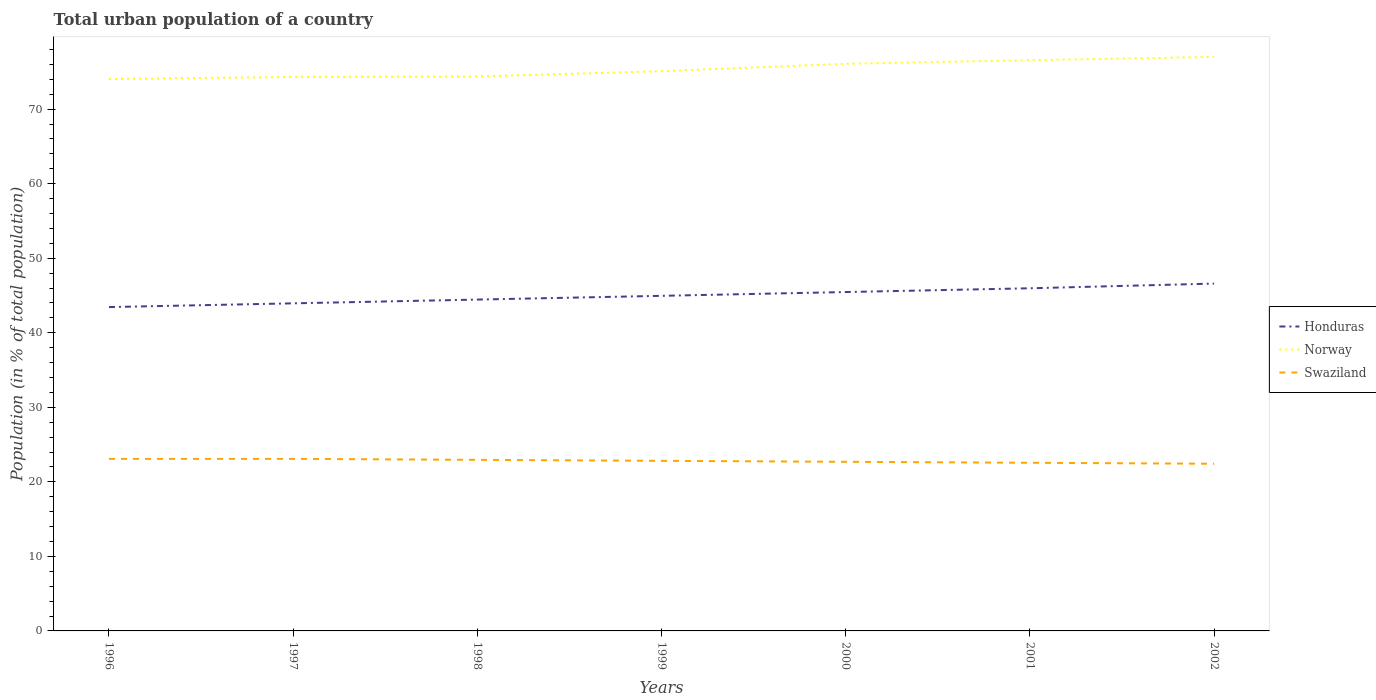Does the line corresponding to Honduras intersect with the line corresponding to Swaziland?
Offer a very short reply. No. Across all years, what is the maximum urban population in Swaziland?
Your answer should be compact. 22.43. In which year was the urban population in Norway maximum?
Your answer should be very brief. 1996. What is the total urban population in Honduras in the graph?
Provide a succinct answer. -1.51. What is the difference between the highest and the second highest urban population in Swaziland?
Keep it short and to the point. 0.66. Does the graph contain grids?
Give a very brief answer. No. How many legend labels are there?
Make the answer very short. 3. What is the title of the graph?
Provide a short and direct response. Total urban population of a country. Does "Barbados" appear as one of the legend labels in the graph?
Make the answer very short. No. What is the label or title of the Y-axis?
Give a very brief answer. Population (in % of total population). What is the Population (in % of total population) in Honduras in 1996?
Your response must be concise. 43.44. What is the Population (in % of total population) of Norway in 1996?
Provide a succinct answer. 74.04. What is the Population (in % of total population) in Swaziland in 1996?
Provide a short and direct response. 23.08. What is the Population (in % of total population) of Honduras in 1997?
Provide a succinct answer. 43.94. What is the Population (in % of total population) in Norway in 1997?
Ensure brevity in your answer.  74.31. What is the Population (in % of total population) in Swaziland in 1997?
Offer a terse response. 23.08. What is the Population (in % of total population) of Honduras in 1998?
Keep it short and to the point. 44.45. What is the Population (in % of total population) in Norway in 1998?
Your response must be concise. 74.38. What is the Population (in % of total population) in Swaziland in 1998?
Offer a very short reply. 22.95. What is the Population (in % of total population) of Honduras in 1999?
Give a very brief answer. 44.95. What is the Population (in % of total population) of Norway in 1999?
Provide a succinct answer. 75.09. What is the Population (in % of total population) of Swaziland in 1999?
Offer a terse response. 22.82. What is the Population (in % of total population) in Honduras in 2000?
Keep it short and to the point. 45.46. What is the Population (in % of total population) of Norway in 2000?
Your answer should be very brief. 76.08. What is the Population (in % of total population) in Swaziland in 2000?
Your answer should be very brief. 22.69. What is the Population (in % of total population) of Honduras in 2001?
Your answer should be very brief. 45.96. What is the Population (in % of total population) of Norway in 2001?
Your response must be concise. 76.56. What is the Population (in % of total population) in Swaziland in 2001?
Your answer should be very brief. 22.55. What is the Population (in % of total population) of Honduras in 2002?
Your response must be concise. 46.59. What is the Population (in % of total population) in Norway in 2002?
Provide a succinct answer. 77. What is the Population (in % of total population) of Swaziland in 2002?
Provide a succinct answer. 22.43. Across all years, what is the maximum Population (in % of total population) of Honduras?
Ensure brevity in your answer.  46.59. Across all years, what is the maximum Population (in % of total population) of Norway?
Provide a short and direct response. 77. Across all years, what is the maximum Population (in % of total population) of Swaziland?
Offer a terse response. 23.08. Across all years, what is the minimum Population (in % of total population) in Honduras?
Your answer should be very brief. 43.44. Across all years, what is the minimum Population (in % of total population) of Norway?
Your answer should be compact. 74.04. Across all years, what is the minimum Population (in % of total population) in Swaziland?
Keep it short and to the point. 22.43. What is the total Population (in % of total population) in Honduras in the graph?
Offer a very short reply. 314.8. What is the total Population (in % of total population) in Norway in the graph?
Keep it short and to the point. 527.45. What is the total Population (in % of total population) of Swaziland in the graph?
Offer a terse response. 159.59. What is the difference between the Population (in % of total population) in Honduras in 1996 and that in 1997?
Your response must be concise. -0.5. What is the difference between the Population (in % of total population) of Norway in 1996 and that in 1997?
Make the answer very short. -0.27. What is the difference between the Population (in % of total population) of Swaziland in 1996 and that in 1997?
Provide a short and direct response. -0.01. What is the difference between the Population (in % of total population) of Honduras in 1996 and that in 1998?
Offer a very short reply. -1. What is the difference between the Population (in % of total population) of Norway in 1996 and that in 1998?
Provide a succinct answer. -0.34. What is the difference between the Population (in % of total population) of Swaziland in 1996 and that in 1998?
Your answer should be very brief. 0.13. What is the difference between the Population (in % of total population) in Honduras in 1996 and that in 1999?
Provide a short and direct response. -1.51. What is the difference between the Population (in % of total population) of Norway in 1996 and that in 1999?
Your response must be concise. -1.05. What is the difference between the Population (in % of total population) in Swaziland in 1996 and that in 1999?
Ensure brevity in your answer.  0.26. What is the difference between the Population (in % of total population) of Honduras in 1996 and that in 2000?
Your answer should be very brief. -2.02. What is the difference between the Population (in % of total population) in Norway in 1996 and that in 2000?
Keep it short and to the point. -2.04. What is the difference between the Population (in % of total population) in Swaziland in 1996 and that in 2000?
Provide a succinct answer. 0.39. What is the difference between the Population (in % of total population) of Honduras in 1996 and that in 2001?
Give a very brief answer. -2.52. What is the difference between the Population (in % of total population) in Norway in 1996 and that in 2001?
Ensure brevity in your answer.  -2.52. What is the difference between the Population (in % of total population) in Swaziland in 1996 and that in 2001?
Provide a short and direct response. 0.52. What is the difference between the Population (in % of total population) of Honduras in 1996 and that in 2002?
Offer a terse response. -3.15. What is the difference between the Population (in % of total population) of Norway in 1996 and that in 2002?
Make the answer very short. -2.96. What is the difference between the Population (in % of total population) of Swaziland in 1996 and that in 2002?
Your answer should be compact. 0.65. What is the difference between the Population (in % of total population) in Honduras in 1997 and that in 1998?
Provide a short and direct response. -0.5. What is the difference between the Population (in % of total population) of Norway in 1997 and that in 1998?
Offer a very short reply. -0.07. What is the difference between the Population (in % of total population) of Swaziland in 1997 and that in 1998?
Provide a short and direct response. 0.13. What is the difference between the Population (in % of total population) of Honduras in 1997 and that in 1999?
Offer a very short reply. -1.01. What is the difference between the Population (in % of total population) in Norway in 1997 and that in 1999?
Keep it short and to the point. -0.78. What is the difference between the Population (in % of total population) in Swaziland in 1997 and that in 1999?
Keep it short and to the point. 0.26. What is the difference between the Population (in % of total population) of Honduras in 1997 and that in 2000?
Your response must be concise. -1.51. What is the difference between the Population (in % of total population) of Norway in 1997 and that in 2000?
Your answer should be very brief. -1.77. What is the difference between the Population (in % of total population) of Swaziland in 1997 and that in 2000?
Ensure brevity in your answer.  0.4. What is the difference between the Population (in % of total population) of Honduras in 1997 and that in 2001?
Make the answer very short. -2.02. What is the difference between the Population (in % of total population) in Norway in 1997 and that in 2001?
Make the answer very short. -2.25. What is the difference between the Population (in % of total population) of Swaziland in 1997 and that in 2001?
Provide a succinct answer. 0.53. What is the difference between the Population (in % of total population) in Honduras in 1997 and that in 2002?
Provide a succinct answer. -2.65. What is the difference between the Population (in % of total population) in Norway in 1997 and that in 2002?
Give a very brief answer. -2.69. What is the difference between the Population (in % of total population) in Swaziland in 1997 and that in 2002?
Offer a very short reply. 0.66. What is the difference between the Population (in % of total population) of Honduras in 1998 and that in 1999?
Keep it short and to the point. -0.51. What is the difference between the Population (in % of total population) in Norway in 1998 and that in 1999?
Provide a succinct answer. -0.71. What is the difference between the Population (in % of total population) in Swaziland in 1998 and that in 1999?
Keep it short and to the point. 0.13. What is the difference between the Population (in % of total population) in Honduras in 1998 and that in 2000?
Provide a short and direct response. -1.01. What is the difference between the Population (in % of total population) of Norway in 1998 and that in 2000?
Make the answer very short. -1.71. What is the difference between the Population (in % of total population) of Swaziland in 1998 and that in 2000?
Give a very brief answer. 0.26. What is the difference between the Population (in % of total population) of Honduras in 1998 and that in 2001?
Your response must be concise. -1.52. What is the difference between the Population (in % of total population) in Norway in 1998 and that in 2001?
Offer a terse response. -2.19. What is the difference between the Population (in % of total population) in Swaziland in 1998 and that in 2001?
Make the answer very short. 0.39. What is the difference between the Population (in % of total population) of Honduras in 1998 and that in 2002?
Provide a short and direct response. -2.15. What is the difference between the Population (in % of total population) of Norway in 1998 and that in 2002?
Provide a short and direct response. -2.62. What is the difference between the Population (in % of total population) in Swaziland in 1998 and that in 2002?
Your response must be concise. 0.52. What is the difference between the Population (in % of total population) in Honduras in 1999 and that in 2000?
Ensure brevity in your answer.  -0.51. What is the difference between the Population (in % of total population) of Norway in 1999 and that in 2000?
Your answer should be compact. -0.99. What is the difference between the Population (in % of total population) in Swaziland in 1999 and that in 2000?
Provide a short and direct response. 0.13. What is the difference between the Population (in % of total population) of Honduras in 1999 and that in 2001?
Ensure brevity in your answer.  -1.01. What is the difference between the Population (in % of total population) in Norway in 1999 and that in 2001?
Give a very brief answer. -1.48. What is the difference between the Population (in % of total population) in Swaziland in 1999 and that in 2001?
Give a very brief answer. 0.26. What is the difference between the Population (in % of total population) in Honduras in 1999 and that in 2002?
Give a very brief answer. -1.64. What is the difference between the Population (in % of total population) in Norway in 1999 and that in 2002?
Your response must be concise. -1.91. What is the difference between the Population (in % of total population) of Swaziland in 1999 and that in 2002?
Make the answer very short. 0.39. What is the difference between the Population (in % of total population) in Honduras in 2000 and that in 2001?
Provide a short and direct response. -0.51. What is the difference between the Population (in % of total population) in Norway in 2000 and that in 2001?
Provide a succinct answer. -0.48. What is the difference between the Population (in % of total population) of Swaziland in 2000 and that in 2001?
Your answer should be very brief. 0.13. What is the difference between the Population (in % of total population) in Honduras in 2000 and that in 2002?
Offer a terse response. -1.14. What is the difference between the Population (in % of total population) in Norway in 2000 and that in 2002?
Ensure brevity in your answer.  -0.92. What is the difference between the Population (in % of total population) of Swaziland in 2000 and that in 2002?
Your response must be concise. 0.26. What is the difference between the Population (in % of total population) in Honduras in 2001 and that in 2002?
Your answer should be compact. -0.63. What is the difference between the Population (in % of total population) in Norway in 2001 and that in 2002?
Offer a terse response. -0.44. What is the difference between the Population (in % of total population) of Swaziland in 2001 and that in 2002?
Your response must be concise. 0.13. What is the difference between the Population (in % of total population) of Honduras in 1996 and the Population (in % of total population) of Norway in 1997?
Offer a terse response. -30.87. What is the difference between the Population (in % of total population) of Honduras in 1996 and the Population (in % of total population) of Swaziland in 1997?
Your answer should be compact. 20.36. What is the difference between the Population (in % of total population) in Norway in 1996 and the Population (in % of total population) in Swaziland in 1997?
Ensure brevity in your answer.  50.96. What is the difference between the Population (in % of total population) of Honduras in 1996 and the Population (in % of total population) of Norway in 1998?
Keep it short and to the point. -30.93. What is the difference between the Population (in % of total population) of Honduras in 1996 and the Population (in % of total population) of Swaziland in 1998?
Provide a succinct answer. 20.49. What is the difference between the Population (in % of total population) of Norway in 1996 and the Population (in % of total population) of Swaziland in 1998?
Make the answer very short. 51.09. What is the difference between the Population (in % of total population) in Honduras in 1996 and the Population (in % of total population) in Norway in 1999?
Your answer should be compact. -31.64. What is the difference between the Population (in % of total population) in Honduras in 1996 and the Population (in % of total population) in Swaziland in 1999?
Ensure brevity in your answer.  20.62. What is the difference between the Population (in % of total population) of Norway in 1996 and the Population (in % of total population) of Swaziland in 1999?
Your response must be concise. 51.22. What is the difference between the Population (in % of total population) in Honduras in 1996 and the Population (in % of total population) in Norway in 2000?
Ensure brevity in your answer.  -32.64. What is the difference between the Population (in % of total population) in Honduras in 1996 and the Population (in % of total population) in Swaziland in 2000?
Give a very brief answer. 20.76. What is the difference between the Population (in % of total population) in Norway in 1996 and the Population (in % of total population) in Swaziland in 2000?
Your answer should be compact. 51.35. What is the difference between the Population (in % of total population) of Honduras in 1996 and the Population (in % of total population) of Norway in 2001?
Your answer should be compact. -33.12. What is the difference between the Population (in % of total population) of Honduras in 1996 and the Population (in % of total population) of Swaziland in 2001?
Provide a succinct answer. 20.89. What is the difference between the Population (in % of total population) in Norway in 1996 and the Population (in % of total population) in Swaziland in 2001?
Provide a short and direct response. 51.48. What is the difference between the Population (in % of total population) in Honduras in 1996 and the Population (in % of total population) in Norway in 2002?
Give a very brief answer. -33.56. What is the difference between the Population (in % of total population) of Honduras in 1996 and the Population (in % of total population) of Swaziland in 2002?
Provide a succinct answer. 21.02. What is the difference between the Population (in % of total population) of Norway in 1996 and the Population (in % of total population) of Swaziland in 2002?
Offer a terse response. 51.61. What is the difference between the Population (in % of total population) of Honduras in 1997 and the Population (in % of total population) of Norway in 1998?
Provide a short and direct response. -30.43. What is the difference between the Population (in % of total population) in Honduras in 1997 and the Population (in % of total population) in Swaziland in 1998?
Provide a succinct answer. 21. What is the difference between the Population (in % of total population) of Norway in 1997 and the Population (in % of total population) of Swaziland in 1998?
Offer a terse response. 51.36. What is the difference between the Population (in % of total population) in Honduras in 1997 and the Population (in % of total population) in Norway in 1999?
Offer a very short reply. -31.14. What is the difference between the Population (in % of total population) in Honduras in 1997 and the Population (in % of total population) in Swaziland in 1999?
Offer a very short reply. 21.13. What is the difference between the Population (in % of total population) of Norway in 1997 and the Population (in % of total population) of Swaziland in 1999?
Offer a terse response. 51.49. What is the difference between the Population (in % of total population) in Honduras in 1997 and the Population (in % of total population) in Norway in 2000?
Offer a terse response. -32.14. What is the difference between the Population (in % of total population) of Honduras in 1997 and the Population (in % of total population) of Swaziland in 2000?
Keep it short and to the point. 21.26. What is the difference between the Population (in % of total population) of Norway in 1997 and the Population (in % of total population) of Swaziland in 2000?
Provide a short and direct response. 51.62. What is the difference between the Population (in % of total population) of Honduras in 1997 and the Population (in % of total population) of Norway in 2001?
Give a very brief answer. -32.62. What is the difference between the Population (in % of total population) in Honduras in 1997 and the Population (in % of total population) in Swaziland in 2001?
Provide a succinct answer. 21.39. What is the difference between the Population (in % of total population) in Norway in 1997 and the Population (in % of total population) in Swaziland in 2001?
Keep it short and to the point. 51.75. What is the difference between the Population (in % of total population) in Honduras in 1997 and the Population (in % of total population) in Norway in 2002?
Offer a terse response. -33.05. What is the difference between the Population (in % of total population) in Honduras in 1997 and the Population (in % of total population) in Swaziland in 2002?
Provide a short and direct response. 21.52. What is the difference between the Population (in % of total population) in Norway in 1997 and the Population (in % of total population) in Swaziland in 2002?
Provide a short and direct response. 51.88. What is the difference between the Population (in % of total population) of Honduras in 1998 and the Population (in % of total population) of Norway in 1999?
Ensure brevity in your answer.  -30.64. What is the difference between the Population (in % of total population) in Honduras in 1998 and the Population (in % of total population) in Swaziland in 1999?
Keep it short and to the point. 21.63. What is the difference between the Population (in % of total population) of Norway in 1998 and the Population (in % of total population) of Swaziland in 1999?
Your answer should be very brief. 51.56. What is the difference between the Population (in % of total population) in Honduras in 1998 and the Population (in % of total population) in Norway in 2000?
Make the answer very short. -31.63. What is the difference between the Population (in % of total population) in Honduras in 1998 and the Population (in % of total population) in Swaziland in 2000?
Make the answer very short. 21.76. What is the difference between the Population (in % of total population) of Norway in 1998 and the Population (in % of total population) of Swaziland in 2000?
Your answer should be compact. 51.69. What is the difference between the Population (in % of total population) in Honduras in 1998 and the Population (in % of total population) in Norway in 2001?
Provide a short and direct response. -32.11. What is the difference between the Population (in % of total population) in Honduras in 1998 and the Population (in % of total population) in Swaziland in 2001?
Your response must be concise. 21.89. What is the difference between the Population (in % of total population) of Norway in 1998 and the Population (in % of total population) of Swaziland in 2001?
Your response must be concise. 51.82. What is the difference between the Population (in % of total population) of Honduras in 1998 and the Population (in % of total population) of Norway in 2002?
Make the answer very short. -32.55. What is the difference between the Population (in % of total population) of Honduras in 1998 and the Population (in % of total population) of Swaziland in 2002?
Provide a short and direct response. 22.02. What is the difference between the Population (in % of total population) of Norway in 1998 and the Population (in % of total population) of Swaziland in 2002?
Make the answer very short. 51.95. What is the difference between the Population (in % of total population) in Honduras in 1999 and the Population (in % of total population) in Norway in 2000?
Offer a very short reply. -31.13. What is the difference between the Population (in % of total population) in Honduras in 1999 and the Population (in % of total population) in Swaziland in 2000?
Your response must be concise. 22.27. What is the difference between the Population (in % of total population) in Norway in 1999 and the Population (in % of total population) in Swaziland in 2000?
Give a very brief answer. 52.4. What is the difference between the Population (in % of total population) of Honduras in 1999 and the Population (in % of total population) of Norway in 2001?
Your answer should be very brief. -31.61. What is the difference between the Population (in % of total population) of Honduras in 1999 and the Population (in % of total population) of Swaziland in 2001?
Your answer should be very brief. 22.4. What is the difference between the Population (in % of total population) in Norway in 1999 and the Population (in % of total population) in Swaziland in 2001?
Provide a short and direct response. 52.53. What is the difference between the Population (in % of total population) of Honduras in 1999 and the Population (in % of total population) of Norway in 2002?
Your response must be concise. -32.05. What is the difference between the Population (in % of total population) in Honduras in 1999 and the Population (in % of total population) in Swaziland in 2002?
Offer a terse response. 22.53. What is the difference between the Population (in % of total population) in Norway in 1999 and the Population (in % of total population) in Swaziland in 2002?
Make the answer very short. 52.66. What is the difference between the Population (in % of total population) in Honduras in 2000 and the Population (in % of total population) in Norway in 2001?
Your answer should be very brief. -31.1. What is the difference between the Population (in % of total population) in Honduras in 2000 and the Population (in % of total population) in Swaziland in 2001?
Your answer should be compact. 22.9. What is the difference between the Population (in % of total population) in Norway in 2000 and the Population (in % of total population) in Swaziland in 2001?
Ensure brevity in your answer.  53.53. What is the difference between the Population (in % of total population) in Honduras in 2000 and the Population (in % of total population) in Norway in 2002?
Ensure brevity in your answer.  -31.54. What is the difference between the Population (in % of total population) of Honduras in 2000 and the Population (in % of total population) of Swaziland in 2002?
Your answer should be compact. 23.03. What is the difference between the Population (in % of total population) of Norway in 2000 and the Population (in % of total population) of Swaziland in 2002?
Offer a very short reply. 53.66. What is the difference between the Population (in % of total population) of Honduras in 2001 and the Population (in % of total population) of Norway in 2002?
Your answer should be compact. -31.04. What is the difference between the Population (in % of total population) of Honduras in 2001 and the Population (in % of total population) of Swaziland in 2002?
Keep it short and to the point. 23.54. What is the difference between the Population (in % of total population) in Norway in 2001 and the Population (in % of total population) in Swaziland in 2002?
Your answer should be very brief. 54.14. What is the average Population (in % of total population) in Honduras per year?
Ensure brevity in your answer.  44.97. What is the average Population (in % of total population) of Norway per year?
Your answer should be compact. 75.35. What is the average Population (in % of total population) in Swaziland per year?
Provide a succinct answer. 22.8. In the year 1996, what is the difference between the Population (in % of total population) of Honduras and Population (in % of total population) of Norway?
Keep it short and to the point. -30.6. In the year 1996, what is the difference between the Population (in % of total population) in Honduras and Population (in % of total population) in Swaziland?
Provide a short and direct response. 20.37. In the year 1996, what is the difference between the Population (in % of total population) of Norway and Population (in % of total population) of Swaziland?
Provide a short and direct response. 50.96. In the year 1997, what is the difference between the Population (in % of total population) of Honduras and Population (in % of total population) of Norway?
Give a very brief answer. -30.36. In the year 1997, what is the difference between the Population (in % of total population) of Honduras and Population (in % of total population) of Swaziland?
Provide a succinct answer. 20.86. In the year 1997, what is the difference between the Population (in % of total population) of Norway and Population (in % of total population) of Swaziland?
Your response must be concise. 51.23. In the year 1998, what is the difference between the Population (in % of total population) in Honduras and Population (in % of total population) in Norway?
Provide a succinct answer. -29.93. In the year 1998, what is the difference between the Population (in % of total population) of Honduras and Population (in % of total population) of Swaziland?
Make the answer very short. 21.5. In the year 1998, what is the difference between the Population (in % of total population) of Norway and Population (in % of total population) of Swaziland?
Give a very brief answer. 51.43. In the year 1999, what is the difference between the Population (in % of total population) in Honduras and Population (in % of total population) in Norway?
Your answer should be very brief. -30.13. In the year 1999, what is the difference between the Population (in % of total population) in Honduras and Population (in % of total population) in Swaziland?
Your answer should be very brief. 22.14. In the year 1999, what is the difference between the Population (in % of total population) of Norway and Population (in % of total population) of Swaziland?
Your answer should be compact. 52.27. In the year 2000, what is the difference between the Population (in % of total population) of Honduras and Population (in % of total population) of Norway?
Your response must be concise. -30.62. In the year 2000, what is the difference between the Population (in % of total population) in Honduras and Population (in % of total population) in Swaziland?
Keep it short and to the point. 22.77. In the year 2000, what is the difference between the Population (in % of total population) of Norway and Population (in % of total population) of Swaziland?
Provide a short and direct response. 53.4. In the year 2001, what is the difference between the Population (in % of total population) of Honduras and Population (in % of total population) of Norway?
Give a very brief answer. -30.6. In the year 2001, what is the difference between the Population (in % of total population) in Honduras and Population (in % of total population) in Swaziland?
Give a very brief answer. 23.41. In the year 2001, what is the difference between the Population (in % of total population) in Norway and Population (in % of total population) in Swaziland?
Provide a short and direct response. 54.01. In the year 2002, what is the difference between the Population (in % of total population) in Honduras and Population (in % of total population) in Norway?
Ensure brevity in your answer.  -30.41. In the year 2002, what is the difference between the Population (in % of total population) of Honduras and Population (in % of total population) of Swaziland?
Ensure brevity in your answer.  24.17. In the year 2002, what is the difference between the Population (in % of total population) of Norway and Population (in % of total population) of Swaziland?
Offer a terse response. 54.57. What is the ratio of the Population (in % of total population) of Honduras in 1996 to that in 1997?
Provide a short and direct response. 0.99. What is the ratio of the Population (in % of total population) of Norway in 1996 to that in 1997?
Offer a terse response. 1. What is the ratio of the Population (in % of total population) of Swaziland in 1996 to that in 1997?
Provide a succinct answer. 1. What is the ratio of the Population (in % of total population) in Honduras in 1996 to that in 1998?
Your answer should be compact. 0.98. What is the ratio of the Population (in % of total population) in Honduras in 1996 to that in 1999?
Ensure brevity in your answer.  0.97. What is the ratio of the Population (in % of total population) in Norway in 1996 to that in 1999?
Offer a terse response. 0.99. What is the ratio of the Population (in % of total population) of Swaziland in 1996 to that in 1999?
Make the answer very short. 1.01. What is the ratio of the Population (in % of total population) of Honduras in 1996 to that in 2000?
Ensure brevity in your answer.  0.96. What is the ratio of the Population (in % of total population) in Norway in 1996 to that in 2000?
Your answer should be compact. 0.97. What is the ratio of the Population (in % of total population) in Swaziland in 1996 to that in 2000?
Your answer should be very brief. 1.02. What is the ratio of the Population (in % of total population) of Honduras in 1996 to that in 2001?
Offer a very short reply. 0.95. What is the ratio of the Population (in % of total population) of Norway in 1996 to that in 2001?
Make the answer very short. 0.97. What is the ratio of the Population (in % of total population) of Swaziland in 1996 to that in 2001?
Ensure brevity in your answer.  1.02. What is the ratio of the Population (in % of total population) in Honduras in 1996 to that in 2002?
Provide a short and direct response. 0.93. What is the ratio of the Population (in % of total population) in Norway in 1996 to that in 2002?
Offer a very short reply. 0.96. What is the ratio of the Population (in % of total population) in Swaziland in 1996 to that in 2002?
Your response must be concise. 1.03. What is the ratio of the Population (in % of total population) in Honduras in 1997 to that in 1998?
Provide a short and direct response. 0.99. What is the ratio of the Population (in % of total population) of Norway in 1997 to that in 1998?
Your answer should be compact. 1. What is the ratio of the Population (in % of total population) of Swaziland in 1997 to that in 1998?
Ensure brevity in your answer.  1.01. What is the ratio of the Population (in % of total population) in Honduras in 1997 to that in 1999?
Ensure brevity in your answer.  0.98. What is the ratio of the Population (in % of total population) of Swaziland in 1997 to that in 1999?
Your response must be concise. 1.01. What is the ratio of the Population (in % of total population) of Honduras in 1997 to that in 2000?
Your answer should be very brief. 0.97. What is the ratio of the Population (in % of total population) of Norway in 1997 to that in 2000?
Give a very brief answer. 0.98. What is the ratio of the Population (in % of total population) in Swaziland in 1997 to that in 2000?
Provide a short and direct response. 1.02. What is the ratio of the Population (in % of total population) of Honduras in 1997 to that in 2001?
Your answer should be very brief. 0.96. What is the ratio of the Population (in % of total population) in Norway in 1997 to that in 2001?
Make the answer very short. 0.97. What is the ratio of the Population (in % of total population) in Swaziland in 1997 to that in 2001?
Provide a short and direct response. 1.02. What is the ratio of the Population (in % of total population) in Honduras in 1997 to that in 2002?
Make the answer very short. 0.94. What is the ratio of the Population (in % of total population) of Norway in 1997 to that in 2002?
Your answer should be very brief. 0.97. What is the ratio of the Population (in % of total population) of Swaziland in 1997 to that in 2002?
Provide a short and direct response. 1.03. What is the ratio of the Population (in % of total population) in Honduras in 1998 to that in 1999?
Your answer should be very brief. 0.99. What is the ratio of the Population (in % of total population) in Norway in 1998 to that in 1999?
Give a very brief answer. 0.99. What is the ratio of the Population (in % of total population) in Swaziland in 1998 to that in 1999?
Your answer should be very brief. 1.01. What is the ratio of the Population (in % of total population) in Honduras in 1998 to that in 2000?
Give a very brief answer. 0.98. What is the ratio of the Population (in % of total population) of Norway in 1998 to that in 2000?
Provide a succinct answer. 0.98. What is the ratio of the Population (in % of total population) in Swaziland in 1998 to that in 2000?
Your response must be concise. 1.01. What is the ratio of the Population (in % of total population) of Norway in 1998 to that in 2001?
Keep it short and to the point. 0.97. What is the ratio of the Population (in % of total population) in Swaziland in 1998 to that in 2001?
Provide a succinct answer. 1.02. What is the ratio of the Population (in % of total population) in Honduras in 1998 to that in 2002?
Your response must be concise. 0.95. What is the ratio of the Population (in % of total population) of Norway in 1998 to that in 2002?
Offer a terse response. 0.97. What is the ratio of the Population (in % of total population) in Swaziland in 1998 to that in 2002?
Your answer should be compact. 1.02. What is the ratio of the Population (in % of total population) of Honduras in 1999 to that in 2000?
Your answer should be very brief. 0.99. What is the ratio of the Population (in % of total population) of Norway in 1999 to that in 2000?
Your answer should be compact. 0.99. What is the ratio of the Population (in % of total population) of Honduras in 1999 to that in 2001?
Keep it short and to the point. 0.98. What is the ratio of the Population (in % of total population) in Norway in 1999 to that in 2001?
Your answer should be very brief. 0.98. What is the ratio of the Population (in % of total population) in Swaziland in 1999 to that in 2001?
Offer a terse response. 1.01. What is the ratio of the Population (in % of total population) of Honduras in 1999 to that in 2002?
Offer a very short reply. 0.96. What is the ratio of the Population (in % of total population) of Norway in 1999 to that in 2002?
Keep it short and to the point. 0.98. What is the ratio of the Population (in % of total population) in Swaziland in 1999 to that in 2002?
Your answer should be very brief. 1.02. What is the ratio of the Population (in % of total population) in Swaziland in 2000 to that in 2001?
Keep it short and to the point. 1.01. What is the ratio of the Population (in % of total population) of Honduras in 2000 to that in 2002?
Ensure brevity in your answer.  0.98. What is the ratio of the Population (in % of total population) of Swaziland in 2000 to that in 2002?
Make the answer very short. 1.01. What is the ratio of the Population (in % of total population) in Honduras in 2001 to that in 2002?
Offer a terse response. 0.99. What is the difference between the highest and the second highest Population (in % of total population) in Honduras?
Your answer should be compact. 0.63. What is the difference between the highest and the second highest Population (in % of total population) of Norway?
Your answer should be compact. 0.44. What is the difference between the highest and the second highest Population (in % of total population) in Swaziland?
Your response must be concise. 0.01. What is the difference between the highest and the lowest Population (in % of total population) of Honduras?
Provide a succinct answer. 3.15. What is the difference between the highest and the lowest Population (in % of total population) in Norway?
Make the answer very short. 2.96. What is the difference between the highest and the lowest Population (in % of total population) of Swaziland?
Offer a very short reply. 0.66. 